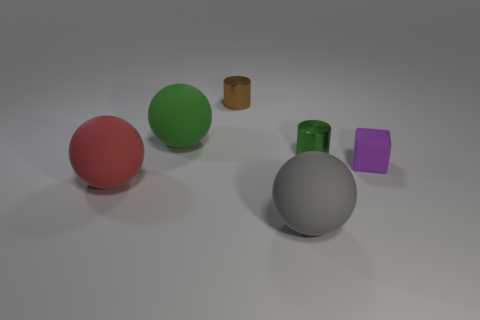There is a matte ball that is behind the big object that is on the left side of the large object that is behind the small purple thing; what color is it?
Make the answer very short. Green. There is a object that is in front of the red matte ball; what shape is it?
Make the answer very short. Sphere. The big gray object that is made of the same material as the tiny purple cube is what shape?
Your answer should be compact. Sphere. Is there anything else that is the same shape as the tiny brown thing?
Your response must be concise. Yes. There is a gray ball; how many tiny cylinders are right of it?
Your answer should be very brief. 1. Are there the same number of tiny blocks behind the purple matte thing and green objects?
Give a very brief answer. No. Does the big gray thing have the same material as the tiny purple block?
Your response must be concise. Yes. There is a rubber object that is both to the left of the gray ball and behind the red object; what size is it?
Your response must be concise. Large. What number of other red rubber objects are the same size as the red thing?
Your response must be concise. 0. What is the size of the shiny cylinder in front of the metal thing that is left of the large gray ball?
Keep it short and to the point. Small. 